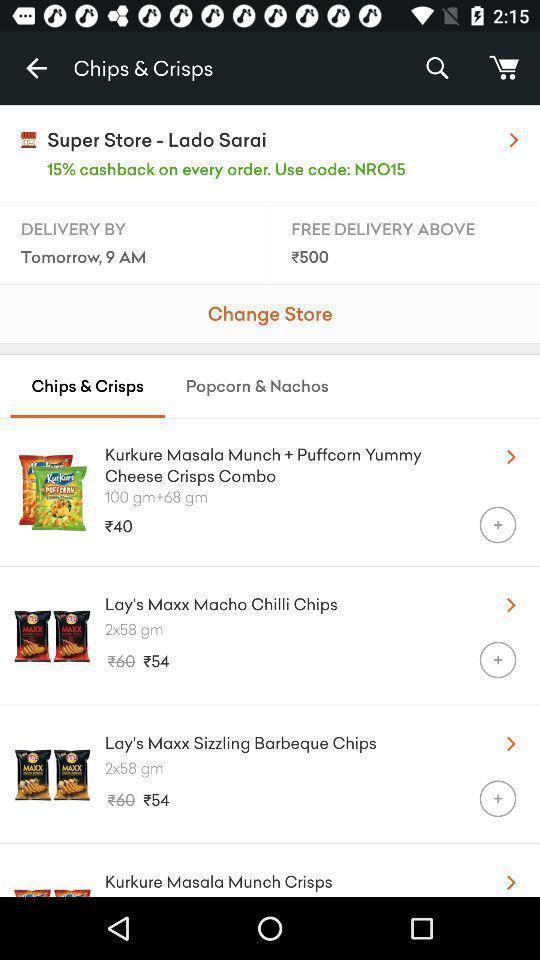Describe the content in this image. Page that displaying snacks items. 